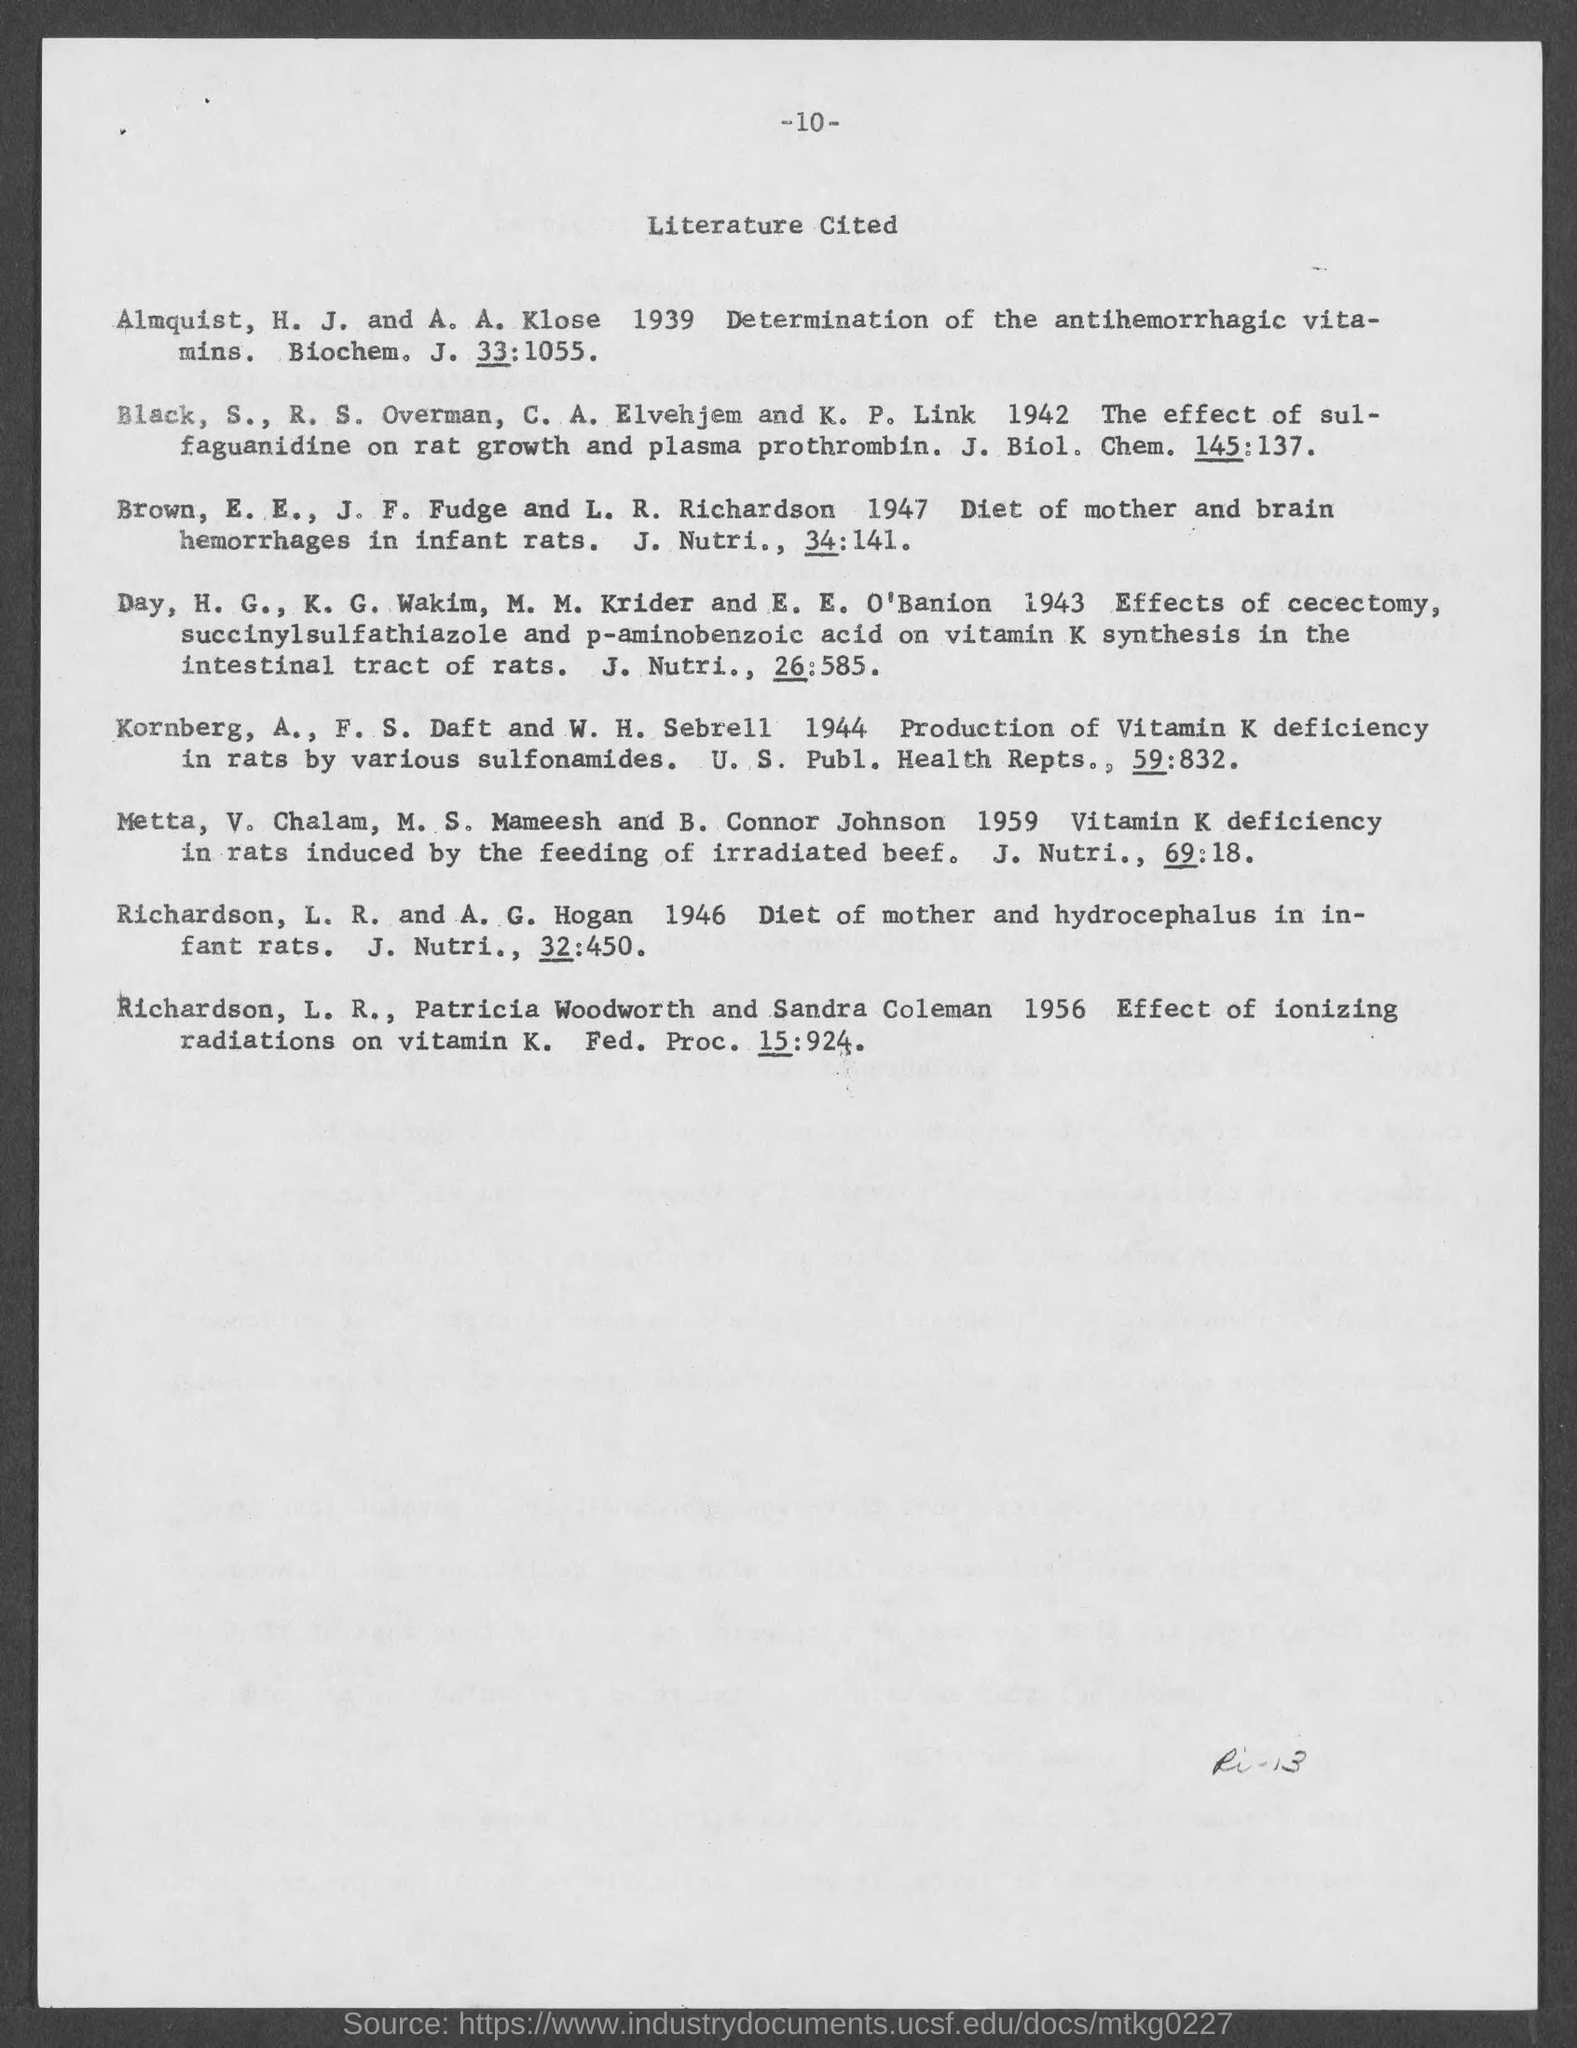What is the page number at top of the page?
Offer a terse response. 10. What is the title of document?
Offer a terse response. Literature cited. 